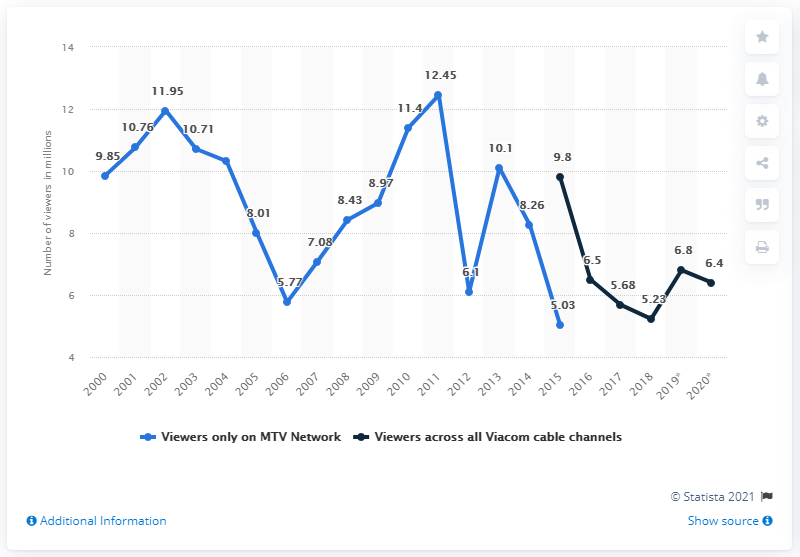Highlight a few significant elements in this photo. In 2020, it is reported that a total of 6.4 Americans watched the MTV Video Music Awards. In the previous year, approximately 6.8 Americans watched the MTV Video Music Awards. 